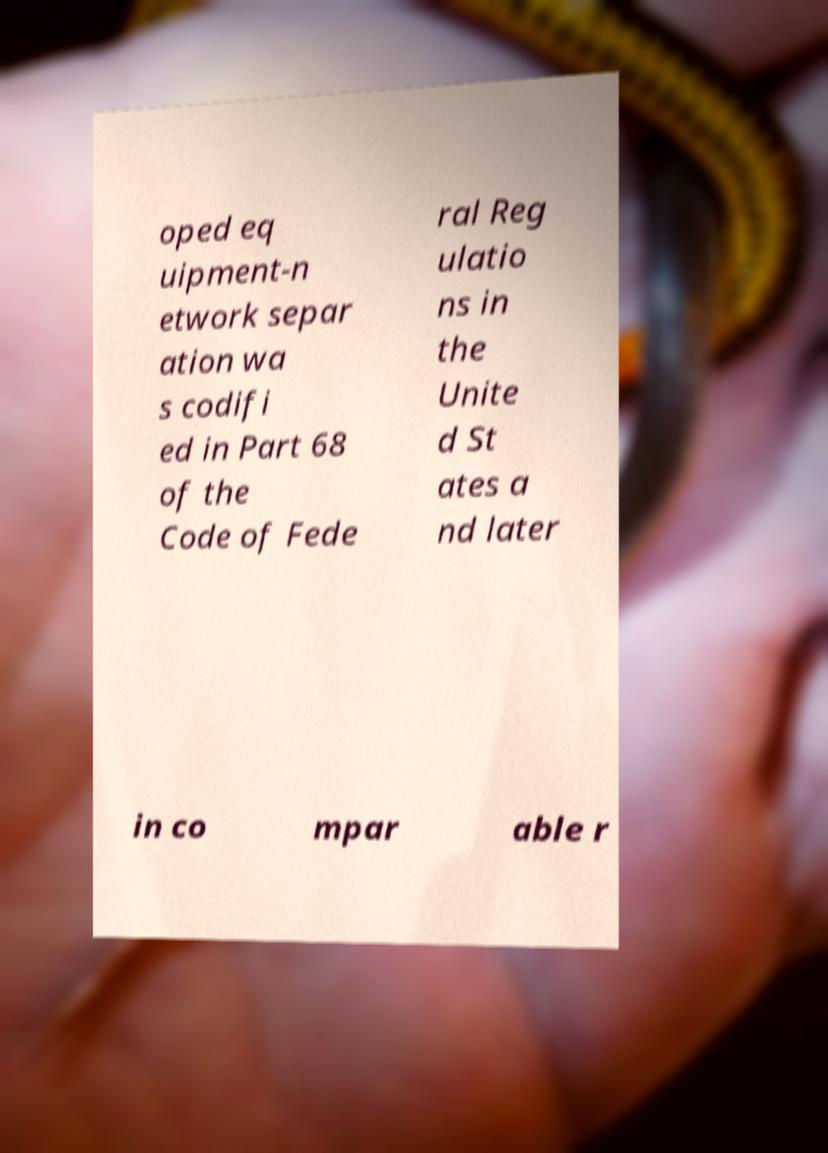I need the written content from this picture converted into text. Can you do that? oped eq uipment-n etwork separ ation wa s codifi ed in Part 68 of the Code of Fede ral Reg ulatio ns in the Unite d St ates a nd later in co mpar able r 